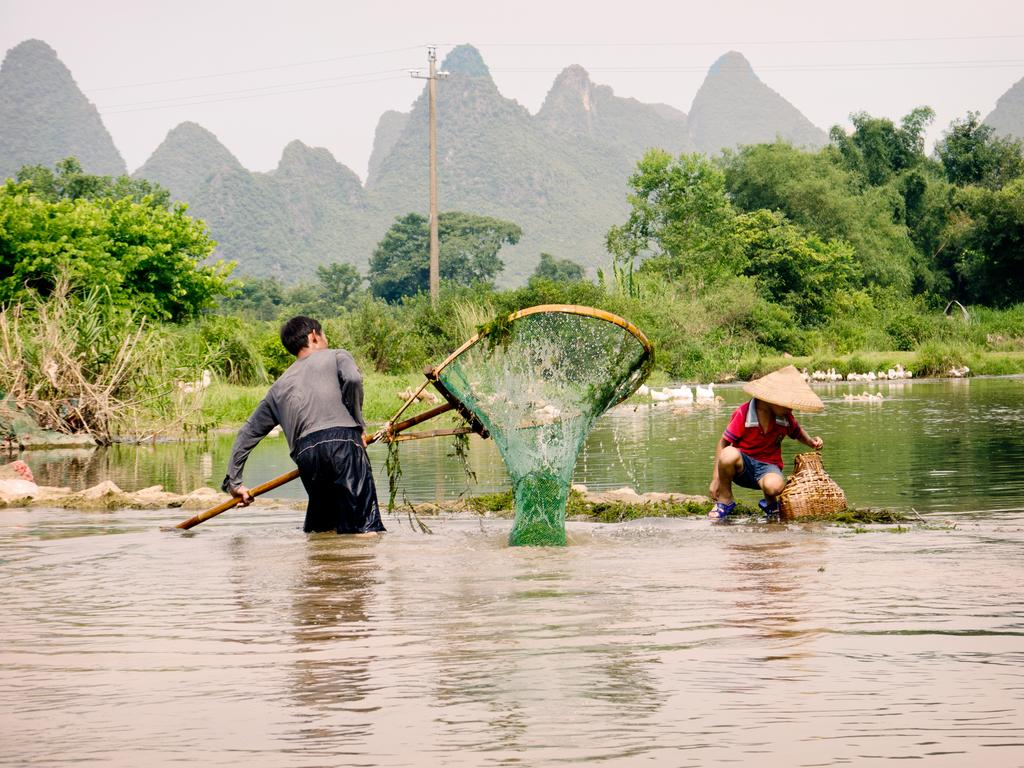What is the primary element visible in the image? There is water in the image. How many people are present in the image? There are two people in the image. What object is used in the image? There is a net in the image. What type of terrain is visible in the image? There is grass in the image. What other natural elements can be seen in the image? There are trees in the image. What structure is present in the image? There is a current pole in the image. What is visible at the top of the image? The sky is visible at the top of the image. What type of chalk is being used by the people in the image? There is no chalk present in the image; it is a water-based scene with a net, grass, trees, and a current pole. 